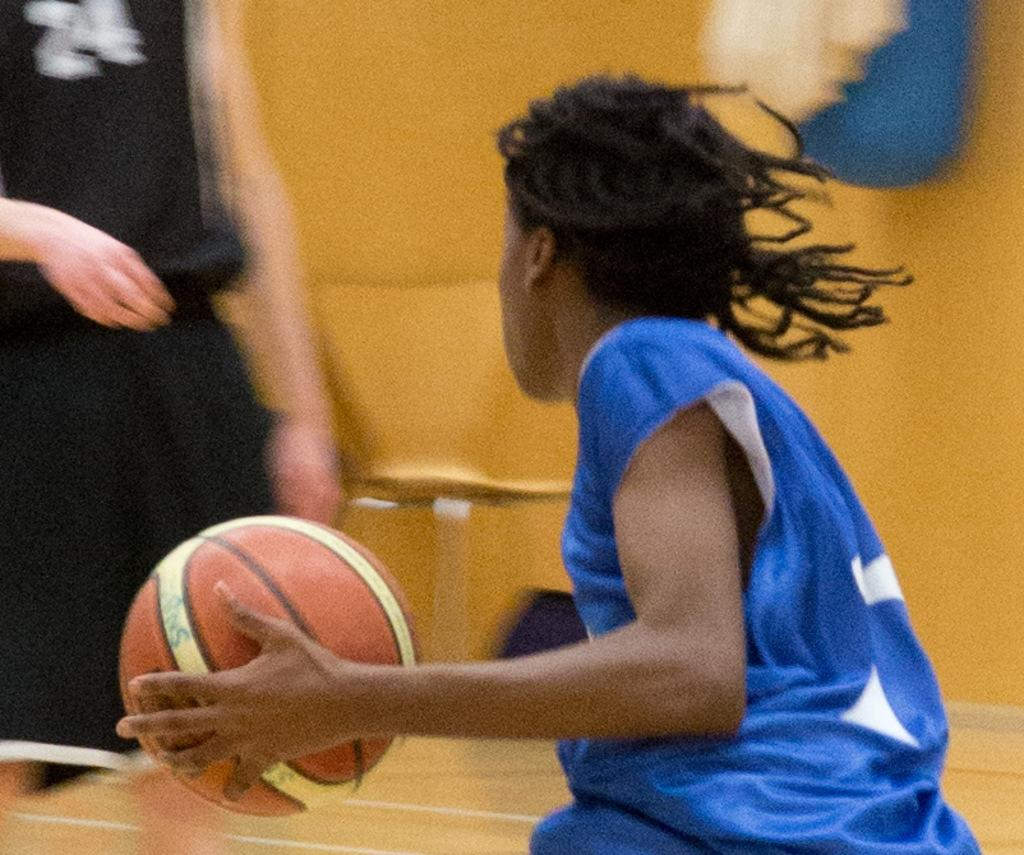Who or what can be seen in the image? There are people in the image. Can you describe the position of the person in the middle of the image? The person is standing in the middle of the image. What is the person holding in the image? The person is holding a ball. What type of volcano can be seen erupting in the background of the image? There is no volcano present in the image; it only features people and a person holding a ball. 